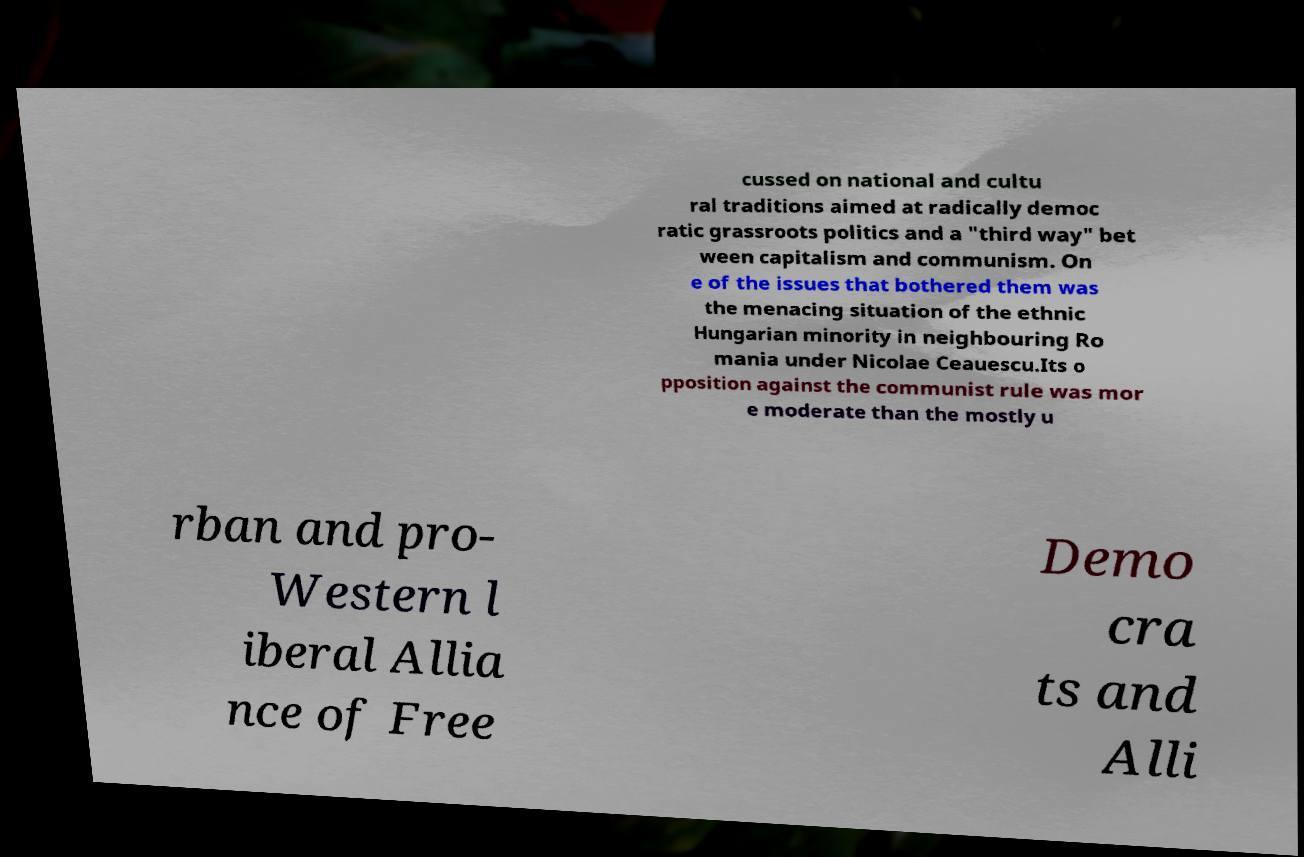Could you extract and type out the text from this image? cussed on national and cultu ral traditions aimed at radically democ ratic grassroots politics and a "third way" bet ween capitalism and communism. On e of the issues that bothered them was the menacing situation of the ethnic Hungarian minority in neighbouring Ro mania under Nicolae Ceauescu.Its o pposition against the communist rule was mor e moderate than the mostly u rban and pro- Western l iberal Allia nce of Free Demo cra ts and Alli 